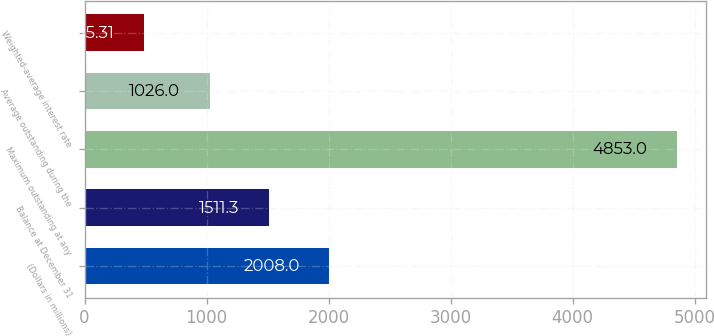Convert chart to OTSL. <chart><loc_0><loc_0><loc_500><loc_500><bar_chart><fcel>(Dollars in millions)<fcel>Balance at December 31<fcel>Maximum outstanding at any<fcel>Average outstanding during the<fcel>Weighted-average interest rate<nl><fcel>2008<fcel>1511.3<fcel>4853<fcel>1026<fcel>485.31<nl></chart> 